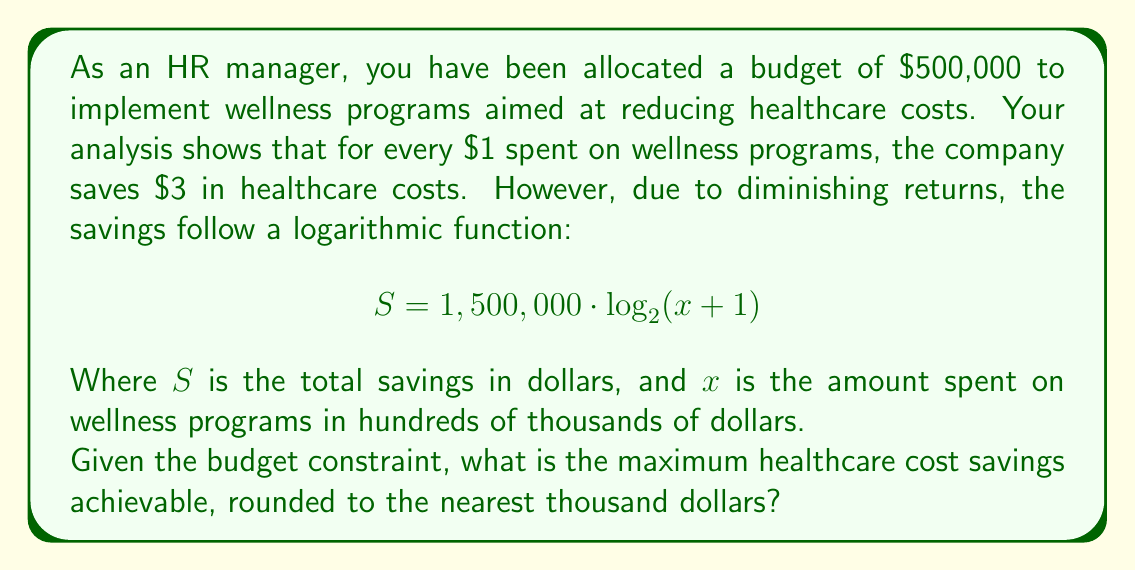Could you help me with this problem? Let's approach this step-by-step:

1) First, we need to understand our constraints:
   - Budget: $500,000
   - $x$ is in hundreds of thousands, so our maximum $x$ is 5

2) Our savings function is:
   $$ S = 1,500,000 \cdot \log_{2}(x+1) $$

3) To find the maximum savings, we need to input our maximum $x$ value:
   $$ S = 1,500,000 \cdot \log_{2}(5+1) $$
   $$ S = 1,500,000 \cdot \log_{2}(6) $$

4) Calculate $\log_{2}(6)$:
   $$ \log_{2}(6) \approx 2.5850 $$

5) Now we can calculate S:
   $$ S = 1,500,000 \cdot 2.5850 $$
   $$ S = 3,877,500 $$

6) Rounding to the nearest thousand:
   $$ S \approx 3,878,000 $$

Therefore, the maximum healthcare cost savings achievable within the budget constraint is approximately $3,878,000.
Answer: $3,878,000 